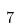<formula> <loc_0><loc_0><loc_500><loc_500>7</formula> 